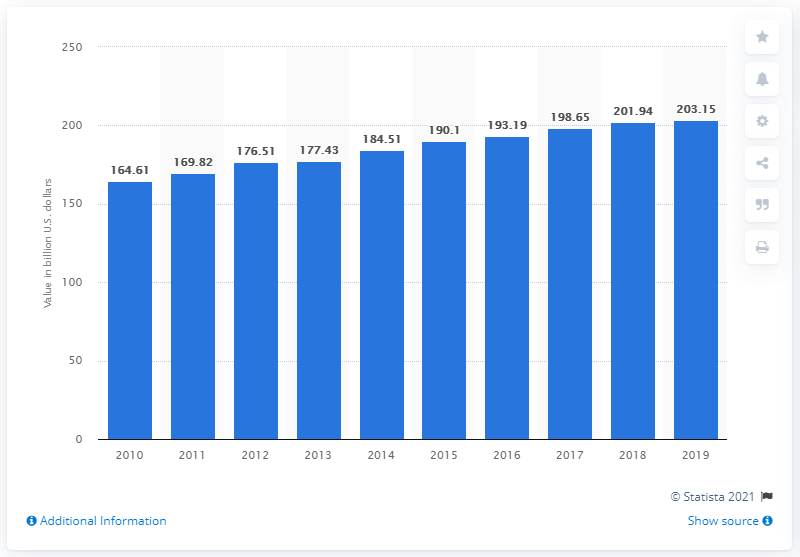Give some essential details in this illustration. In 2019, the manufacturing sector contributed 203.15% to Mexico's GDP. The manufacturing sector contributed 201.94% to Mexico's Gross Domestic Product (GDP) in the previous year, according to the most recent data available. 